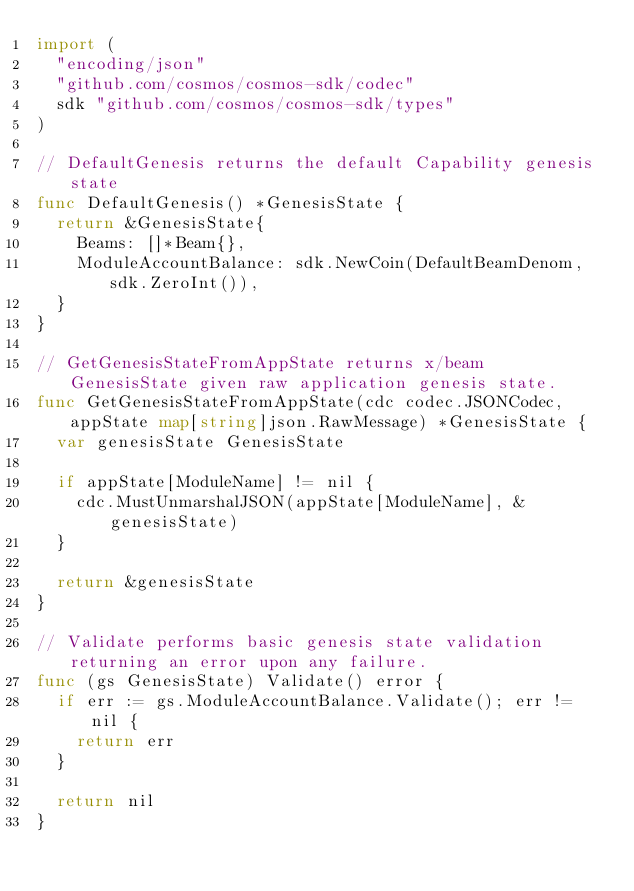Convert code to text. <code><loc_0><loc_0><loc_500><loc_500><_Go_>import (
	"encoding/json"
	"github.com/cosmos/cosmos-sdk/codec"
	sdk "github.com/cosmos/cosmos-sdk/types"
)

// DefaultGenesis returns the default Capability genesis state
func DefaultGenesis() *GenesisState {
	return &GenesisState{
		Beams: []*Beam{},
		ModuleAccountBalance: sdk.NewCoin(DefaultBeamDenom, sdk.ZeroInt()),
	}
}

// GetGenesisStateFromAppState returns x/beam GenesisState given raw application genesis state.
func GetGenesisStateFromAppState(cdc codec.JSONCodec, appState map[string]json.RawMessage) *GenesisState {
	var genesisState GenesisState

	if appState[ModuleName] != nil {
		cdc.MustUnmarshalJSON(appState[ModuleName], &genesisState)
	}

	return &genesisState
}

// Validate performs basic genesis state validation returning an error upon any failure.
func (gs GenesisState) Validate() error {
	if err := gs.ModuleAccountBalance.Validate(); err != nil {
		return err
	}

	return nil
}
</code> 